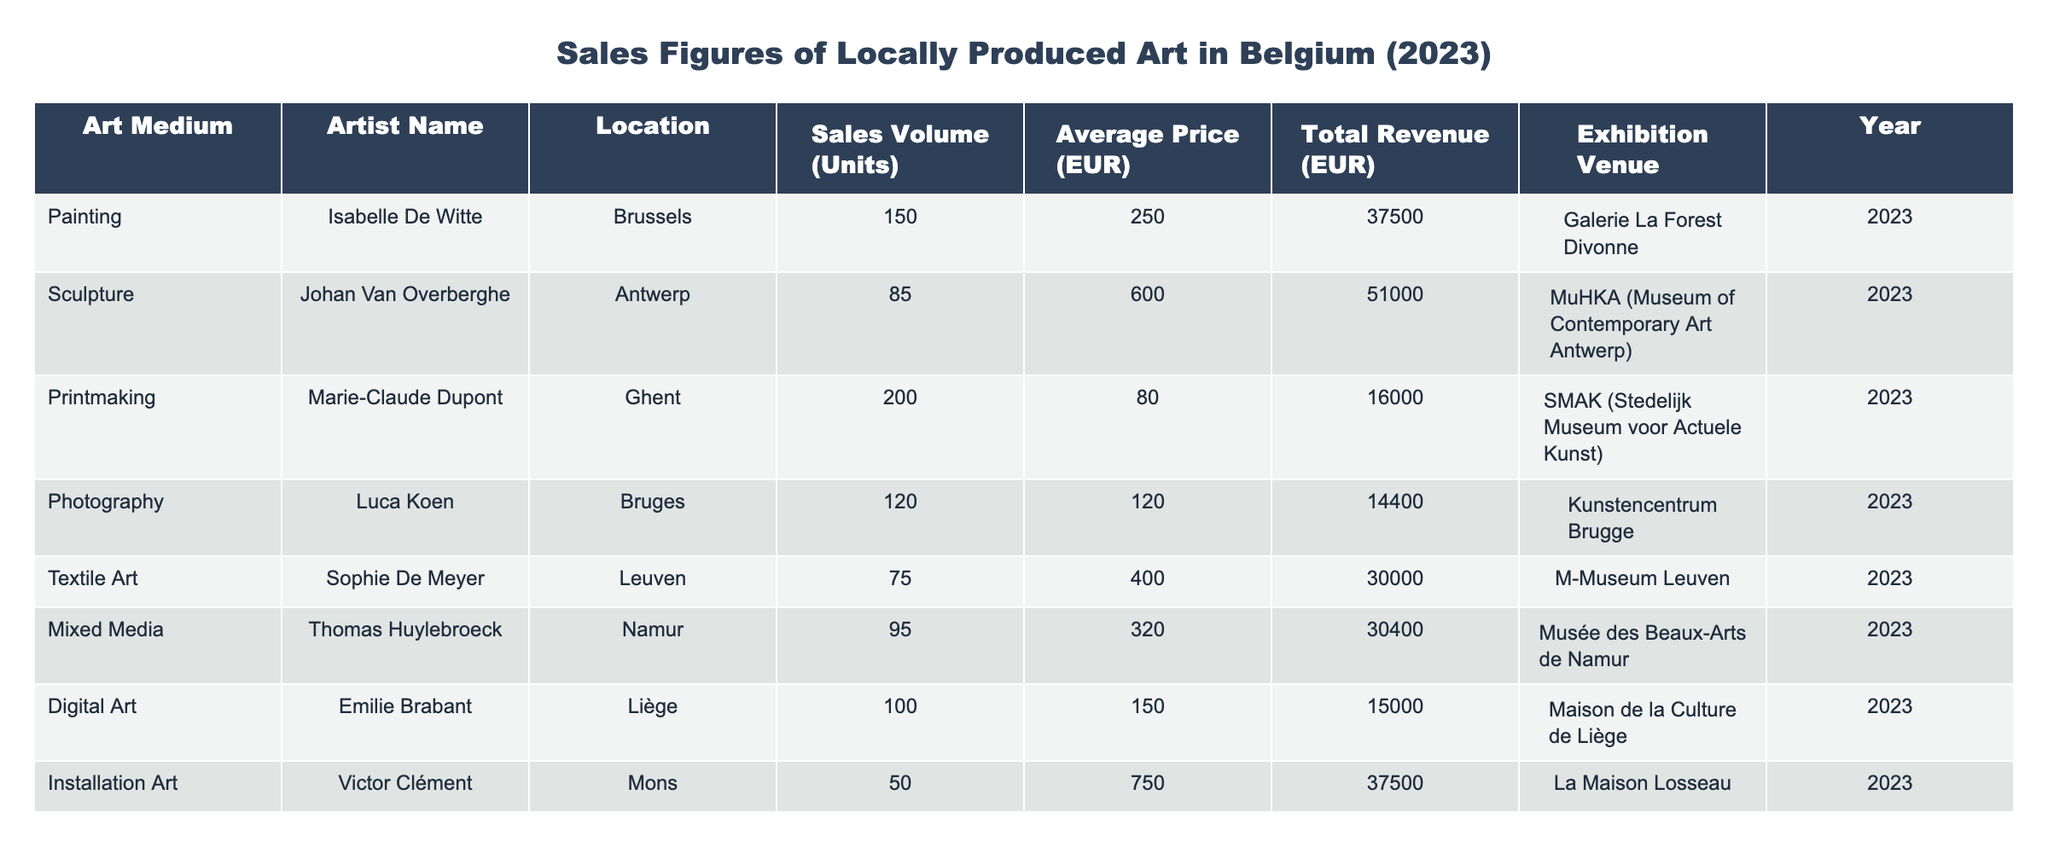What is the total revenue generated from paintings in Belgium for 2023? Looking at the row for paintings, the total revenue is listed as 37,500 EUR for Isabelle De Witte from Brussels.
Answer: 37,500 EUR How many units of sculpture were sold in Antwerp? The table shows that Johan Van Overberghe sold 85 units of sculpture in Antwerp.
Answer: 85 units What artist had the highest average price per unit sold? To determine this, we review the average prices: Isabelle De Witte (250 EUR), Johan Van Overberghe (600 EUR), Marie-Claude Dupont (80 EUR), Luca Koen (120 EUR), Sophie De Meyer (400 EUR), Thomas Huylebroeck (320 EUR), Emilie Brabant (150 EUR), and Victor Clément (750 EUR). The highest average price is 750 EUR from Victor Clément.
Answer: 750 EUR Is the total revenue from textile art greater than that from printmaking? The total revenue for textile art (30,000 EUR) is compared with printmaking (16,000 EUR). Since 30,000 EUR is greater than 16,000 EUR, the statement is true.
Answer: Yes What is the average sales volume of the artworks listed in the table? First, we add the sales volumes: 150 (painting) + 85 (sculpture) + 200 (printmaking) + 120 (photography) + 75 (textile art) + 95 (mixed media) + 100 (digital art) + 50 (installation art) = 975 units. There are 8 artworks, so the average is 975/8 = 121.875.
Answer: 121.875 units Which city had the highest total revenue from locally produced art? From the total revenues: Brussels (37,500 EUR), Antwerp (51,000 EUR), Ghent (16,000 EUR), Bruges (14,400 EUR), Leuven (30,000 EUR), Namur (30,400 EUR), Liège (15,000 EUR), and Mons (37,500 EUR), the highest is from Antwerp with 51,000 EUR.
Answer: Antwerp Did more units of digital art sell compared to mixed media? The sales volume for digital art is 100 units and mixed media is 95 units. Since 100 is greater than 95, more digital art units sold.
Answer: Yes What is the total revenue from all types of art combined in the table? To find this, we sum all total revenues: 37,500 + 51,000 + 16,000 + 14,400 + 30,000 + 30,400 + 15,000 + 37,500 = 230,800 EUR.
Answer: 230,800 EUR 